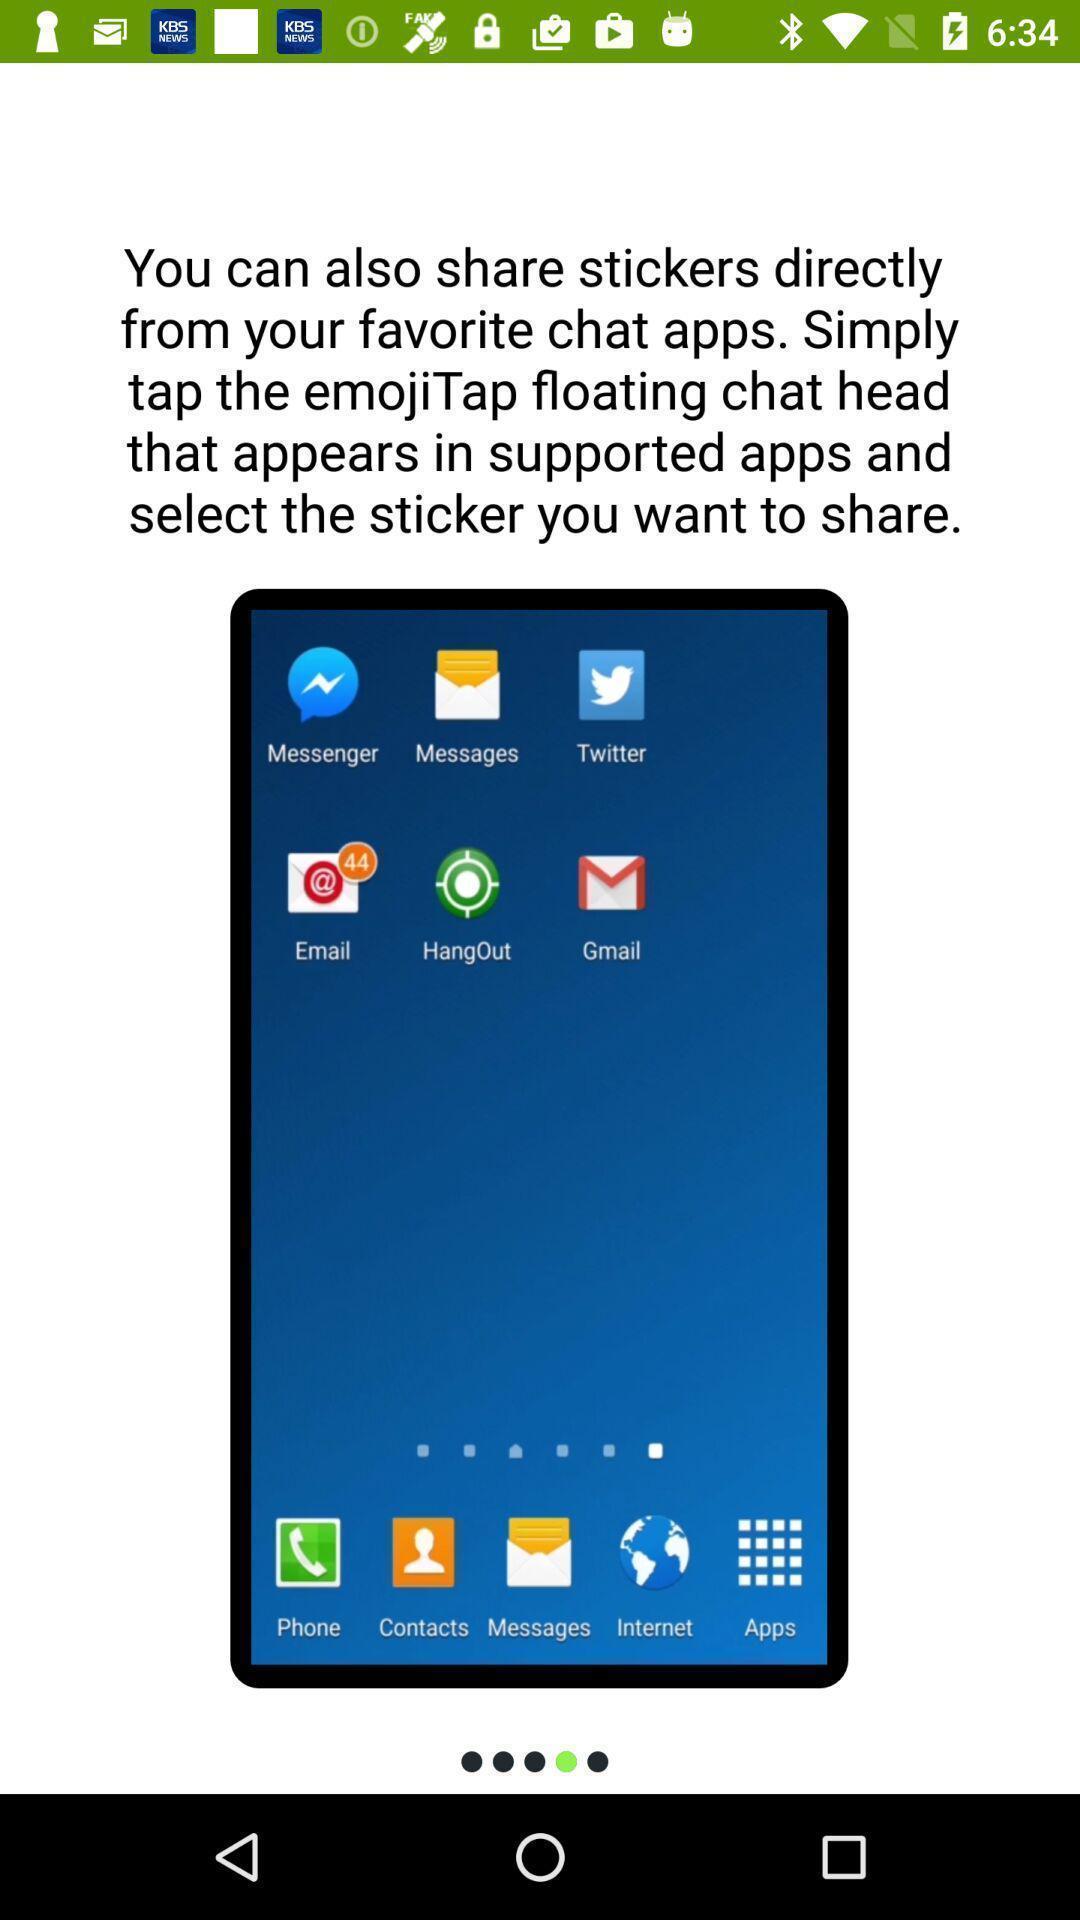What is the overall content of this screenshot? Welcome screen. 